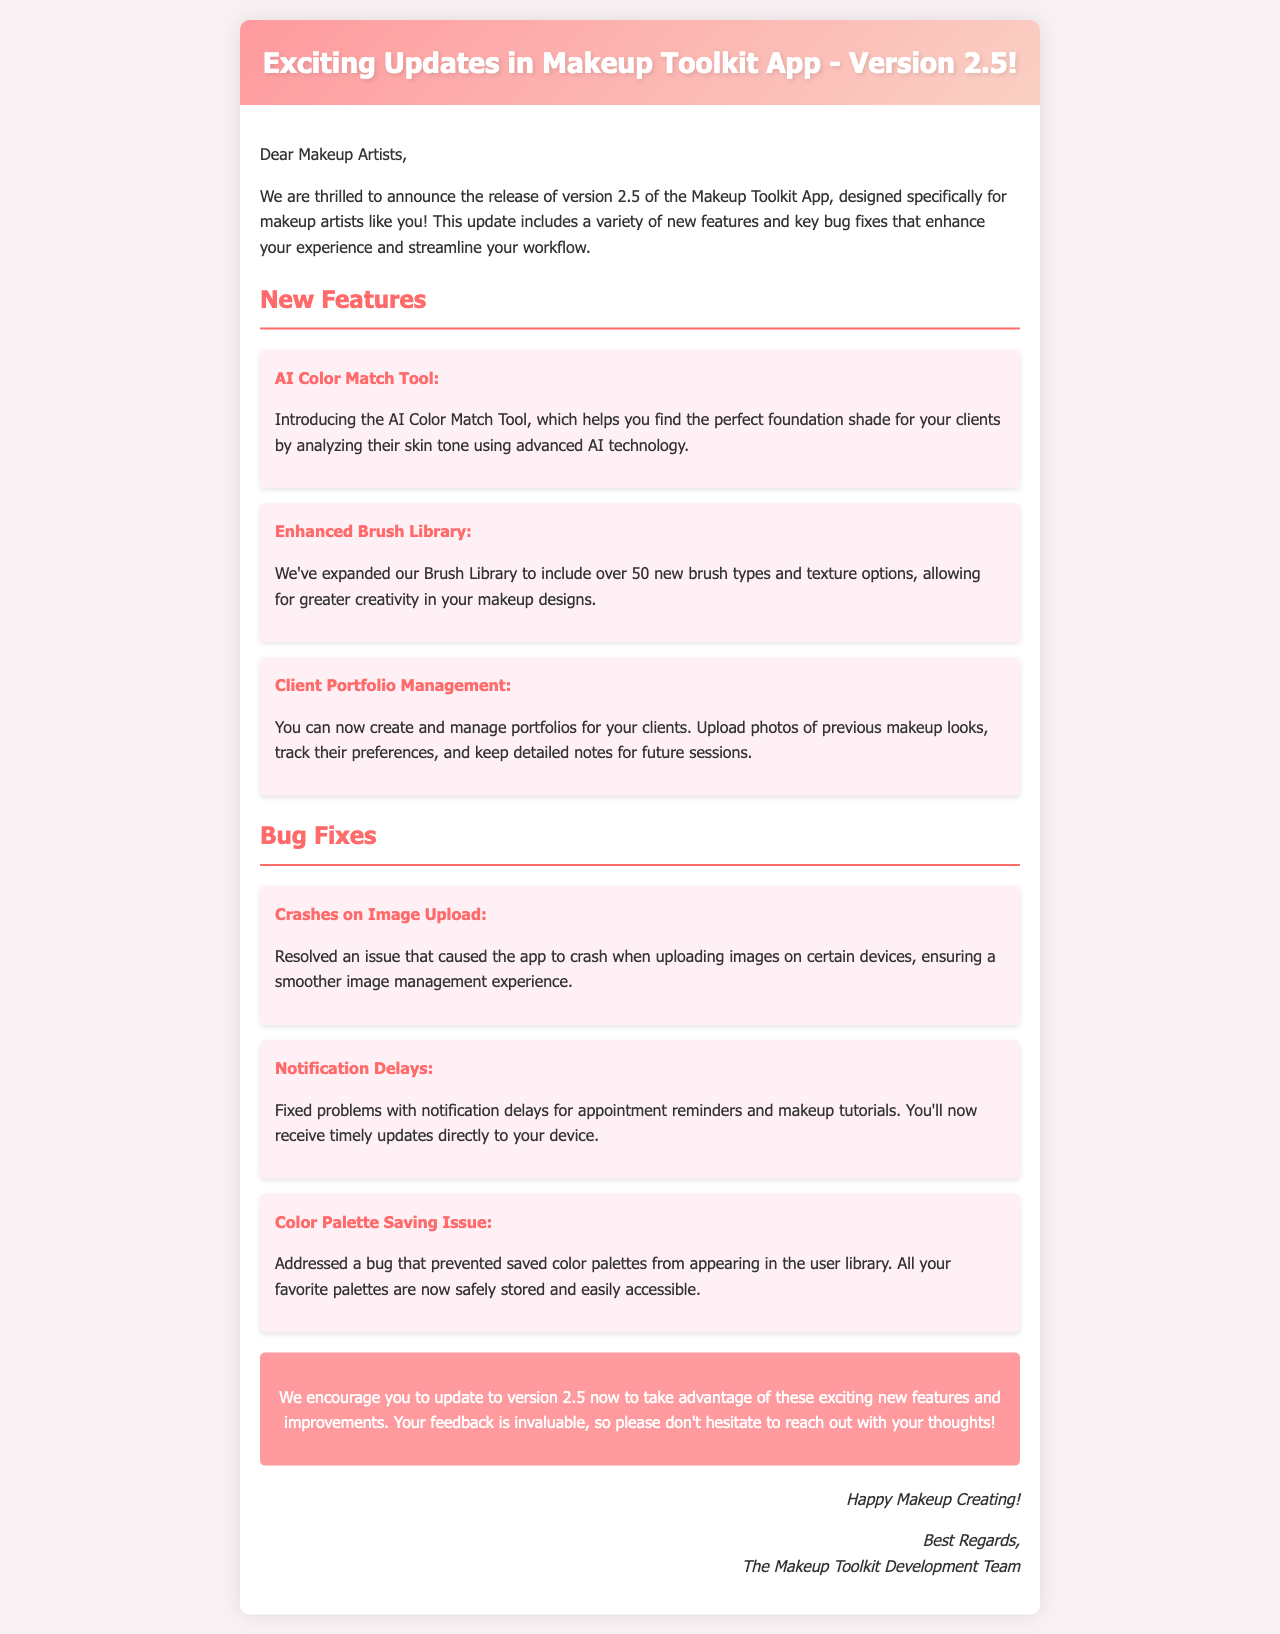what is the version number of the updated Makeup Toolkit app? The document states the release is version 2.5 of the Makeup Toolkit App.
Answer: version 2.5 how many new features are introduced in this update? The document lists three new features in the update.
Answer: three what is the name of the first new feature? The first new feature mentioned is the AI Color Match Tool.
Answer: AI Color Match Tool what bug was resolved related to image uploads? The document specifies that the issue causing the app to crash when uploading images has been resolved.
Answer: crashes on Image Upload what is the purpose of the Client Portfolio Management feature? This feature allows users to create and manage portfolios for clients, including uploading photos and tracking preferences.
Answer: create and manage portfolios how many new brush types and texture options were added? The document states that over 50 new brush types and texture options were added to the Brush Library.
Answer: over 50 what issue was fixed regarding notifications? The document outlines that notification delays for appointment reminders and tutorials were fixed.
Answer: Notification Delays who is encouraged to provide feedback? The document encourages makeup artists to provide their feedback regarding the update.
Answer: makeup artists 